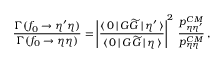<formula> <loc_0><loc_0><loc_500><loc_500>\frac { \Gamma ( f _ { 0 } \to \eta ^ { \prime } \eta ) } { \Gamma ( f _ { 0 } \to \eta \eta ) } = \left | \frac { \langle \, 0 \, | \, G \widetilde { G } \, | \, \eta ^ { \prime } \, \rangle } { \langle \, 0 \, | \, G \widetilde { G } \, | \, \eta \, \rangle } \right | ^ { 2 } \, \frac { p _ { \eta \eta ^ { \prime } } ^ { C M } } { p _ { \eta \eta } ^ { C M } } \, ,</formula> 